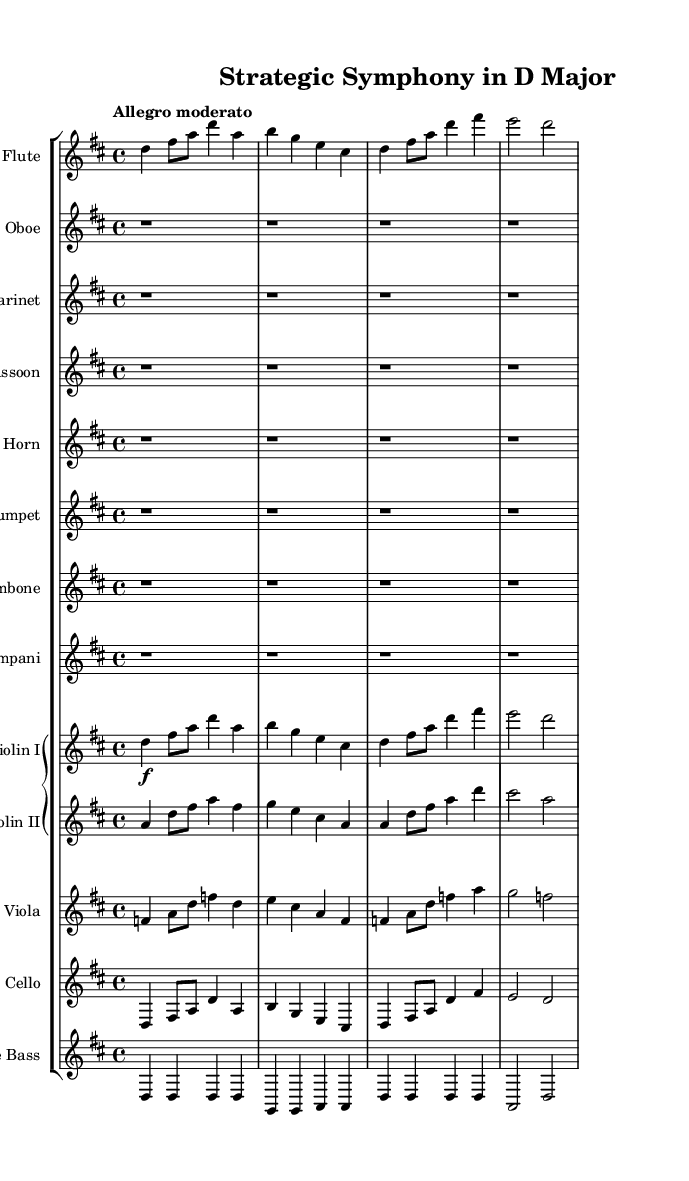What is the key signature of this symphony? The key signature for the piece is indicated as two sharps, which are F# and C#. This corresponds to the key of D major.
Answer: D major What is the time signature? The time signature is found at the beginning of the piece and is noted as 4/4, indicating four beats per measure.
Answer: 4/4 What is the tempo marking of the symphony? The tempo marking "Allegro moderato" suggests a moderately fast tempo. This is typically characterized by a lively and cheerful pace.
Answer: Allegro moderato How many measures does the flute part have? The flute part contains four measures, as indicated by the notation structure divided into four groups of beats.
Answer: 4 Which instruments are playing whole notes in the first section? In the first section, the oboe, clarinet, bassoon, horn, trumpet, trombone, and timpani are all indicated with whole rests, suggesting they are not playing.
Answer: None What melodic interval does the violin I part start with? The violin I part begins with a D to F# interval, which is a major third interval apart. This can be determined by identifying the notes in relation to each other.
Answer: Major third Which instrument plays the bass line primarily throughout the piece? The double bass section plays a consistent bass line that supports the harmonic structure of the symphony, evident through the repeated D notes.
Answer: Double bass 